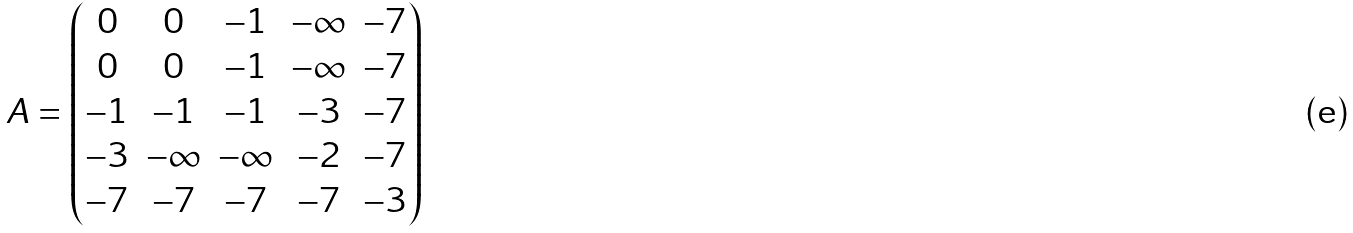Convert formula to latex. <formula><loc_0><loc_0><loc_500><loc_500>A = \begin{pmatrix} 0 & 0 & - 1 & - \infty & - 7 \\ 0 & 0 & - 1 & - \infty & - 7 \\ - 1 & - 1 & - 1 & - 3 & - 7 \\ - 3 & - \infty & - \infty & - 2 & - 7 \\ - 7 & - 7 & - 7 & - 7 & - 3 \end{pmatrix}</formula> 